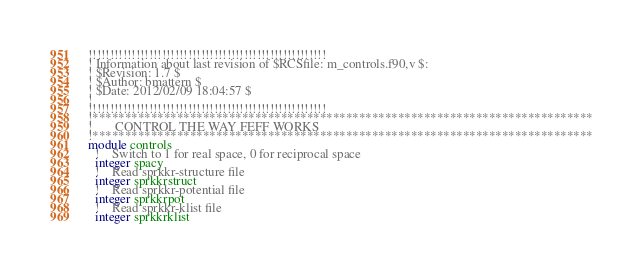Convert code to text. <code><loc_0><loc_0><loc_500><loc_500><_FORTRAN_>!!!!!!!!!!!!!!!!!!!!!!!!!!!!!!!!!!!!!!!!!!!!!!!!!!!!!!!
! Information about last revision of $RCSfile: m_controls.f90,v $:
! $Revision: 1.7 $
! $Author: bmattern $
! $Date: 2012/02/09 18:04:57 $
!
!!!!!!!!!!!!!!!!!!!!!!!!!!!!!!!!!!!!!!!!!!!!!!!!!!!!!!!
!*****************************************************************************
!       CONTROL THE WAY FEFF WORKS
!*****************************************************************************
module controls
  !    Switch to 1 for real space, 0 for reciprocal space
  integer spacy
  !    Read sprkkr-structure file
  integer sprkkrstruct
  !    Read sprkkr-potential file
  integer sprkkrpot
  !    Read sprkkr-klist file
  integer sprkkrklist</code> 